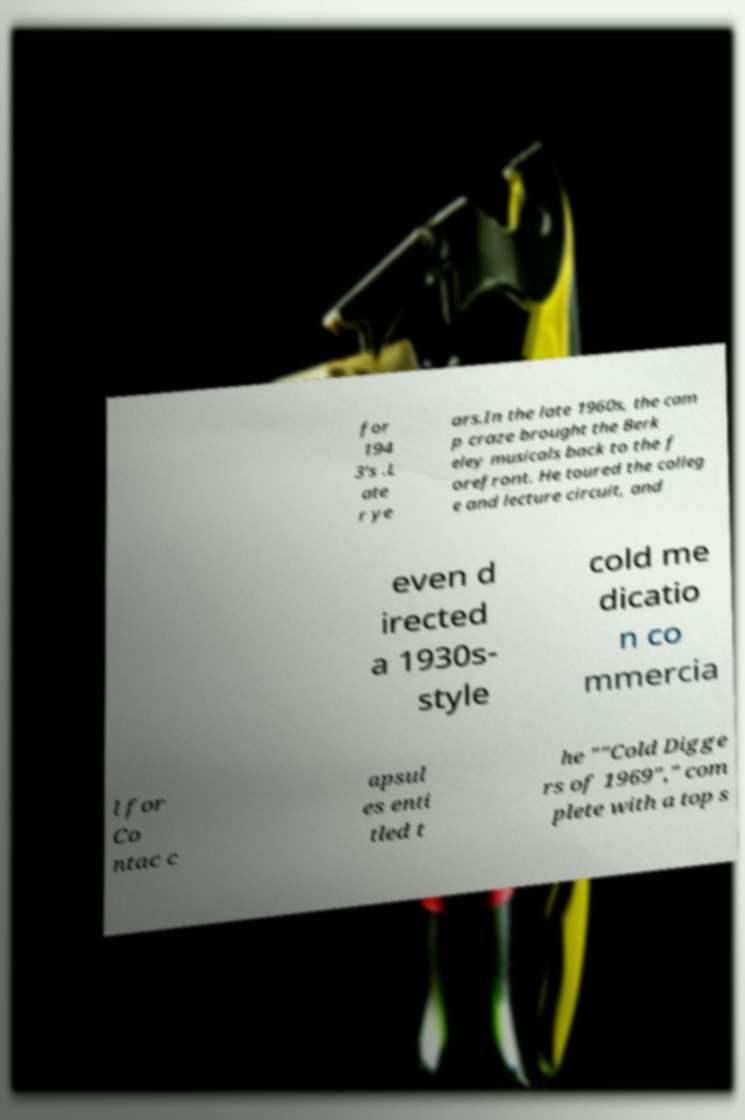Please read and relay the text visible in this image. What does it say? for 194 3's .L ate r ye ars.In the late 1960s, the cam p craze brought the Berk eley musicals back to the f orefront. He toured the colleg e and lecture circuit, and even d irected a 1930s- style cold me dicatio n co mmercia l for Co ntac c apsul es enti tled t he ""Cold Digge rs of 1969"," com plete with a top s 